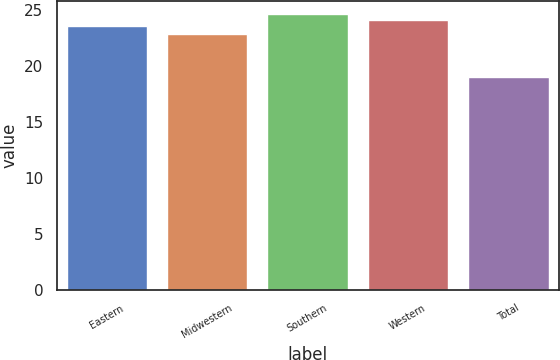<chart> <loc_0><loc_0><loc_500><loc_500><bar_chart><fcel>Eastern<fcel>Midwestern<fcel>Southern<fcel>Western<fcel>Total<nl><fcel>23.5<fcel>22.8<fcel>24.58<fcel>24.04<fcel>19<nl></chart> 